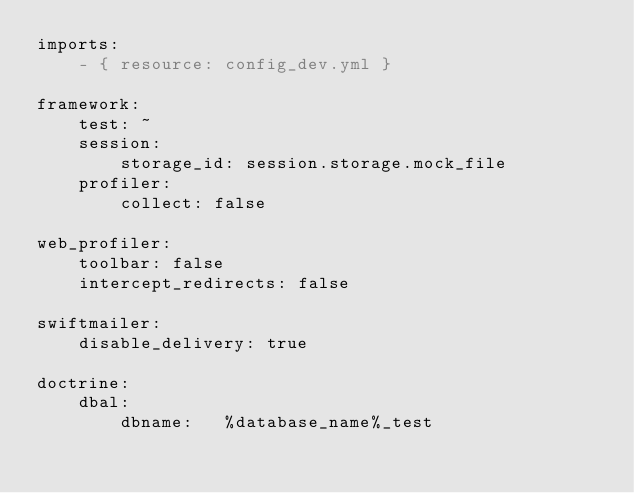Convert code to text. <code><loc_0><loc_0><loc_500><loc_500><_YAML_>imports:
    - { resource: config_dev.yml }

framework:
    test: ~
    session:
        storage_id: session.storage.mock_file
    profiler:
        collect: false

web_profiler:
    toolbar: false
    intercept_redirects: false

swiftmailer:
    disable_delivery: true

doctrine:
    dbal:
        dbname:   %database_name%_test
</code> 